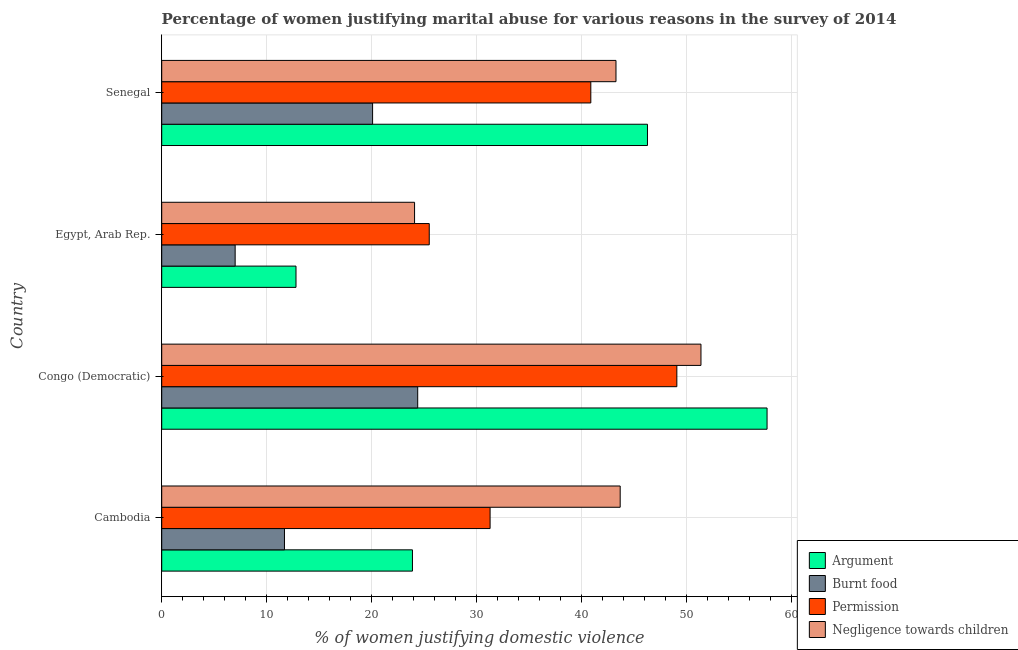How many different coloured bars are there?
Provide a succinct answer. 4. How many groups of bars are there?
Your answer should be compact. 4. Are the number of bars per tick equal to the number of legend labels?
Keep it short and to the point. Yes. How many bars are there on the 2nd tick from the bottom?
Your answer should be very brief. 4. What is the label of the 4th group of bars from the top?
Keep it short and to the point. Cambodia. What is the percentage of women justifying abuse for going without permission in Egypt, Arab Rep.?
Offer a very short reply. 25.5. Across all countries, what is the maximum percentage of women justifying abuse for burning food?
Give a very brief answer. 24.4. Across all countries, what is the minimum percentage of women justifying abuse for showing negligence towards children?
Ensure brevity in your answer.  24.1. In which country was the percentage of women justifying abuse for burning food maximum?
Provide a short and direct response. Congo (Democratic). In which country was the percentage of women justifying abuse for showing negligence towards children minimum?
Offer a very short reply. Egypt, Arab Rep. What is the total percentage of women justifying abuse for burning food in the graph?
Provide a succinct answer. 63.2. What is the difference between the percentage of women justifying abuse for going without permission in Cambodia and that in Senegal?
Make the answer very short. -9.6. What is the difference between the percentage of women justifying abuse in the case of an argument in Egypt, Arab Rep. and the percentage of women justifying abuse for going without permission in Cambodia?
Give a very brief answer. -18.5. What is the average percentage of women justifying abuse in the case of an argument per country?
Offer a very short reply. 35.17. What is the difference between the percentage of women justifying abuse in the case of an argument and percentage of women justifying abuse for showing negligence towards children in Congo (Democratic)?
Your answer should be very brief. 6.3. In how many countries, is the percentage of women justifying abuse in the case of an argument greater than 50 %?
Offer a terse response. 1. What is the ratio of the percentage of women justifying abuse in the case of an argument in Cambodia to that in Egypt, Arab Rep.?
Your answer should be compact. 1.87. Is the percentage of women justifying abuse for going without permission in Congo (Democratic) less than that in Senegal?
Keep it short and to the point. No. What is the difference between the highest and the lowest percentage of women justifying abuse for showing negligence towards children?
Ensure brevity in your answer.  27.3. In how many countries, is the percentage of women justifying abuse for showing negligence towards children greater than the average percentage of women justifying abuse for showing negligence towards children taken over all countries?
Provide a short and direct response. 3. Is the sum of the percentage of women justifying abuse for burning food in Egypt, Arab Rep. and Senegal greater than the maximum percentage of women justifying abuse for showing negligence towards children across all countries?
Provide a short and direct response. No. Is it the case that in every country, the sum of the percentage of women justifying abuse for going without permission and percentage of women justifying abuse in the case of an argument is greater than the sum of percentage of women justifying abuse for burning food and percentage of women justifying abuse for showing negligence towards children?
Provide a succinct answer. Yes. What does the 3rd bar from the top in Congo (Democratic) represents?
Your answer should be very brief. Burnt food. What does the 3rd bar from the bottom in Senegal represents?
Your response must be concise. Permission. How many bars are there?
Keep it short and to the point. 16. How many countries are there in the graph?
Give a very brief answer. 4. Does the graph contain grids?
Make the answer very short. Yes. Where does the legend appear in the graph?
Give a very brief answer. Bottom right. How many legend labels are there?
Your answer should be compact. 4. How are the legend labels stacked?
Make the answer very short. Vertical. What is the title of the graph?
Give a very brief answer. Percentage of women justifying marital abuse for various reasons in the survey of 2014. Does "European Union" appear as one of the legend labels in the graph?
Your answer should be very brief. No. What is the label or title of the X-axis?
Keep it short and to the point. % of women justifying domestic violence. What is the label or title of the Y-axis?
Ensure brevity in your answer.  Country. What is the % of women justifying domestic violence of Argument in Cambodia?
Your answer should be very brief. 23.9. What is the % of women justifying domestic violence of Permission in Cambodia?
Keep it short and to the point. 31.3. What is the % of women justifying domestic violence in Negligence towards children in Cambodia?
Give a very brief answer. 43.7. What is the % of women justifying domestic violence of Argument in Congo (Democratic)?
Offer a very short reply. 57.7. What is the % of women justifying domestic violence in Burnt food in Congo (Democratic)?
Make the answer very short. 24.4. What is the % of women justifying domestic violence in Permission in Congo (Democratic)?
Your answer should be compact. 49.1. What is the % of women justifying domestic violence of Negligence towards children in Congo (Democratic)?
Offer a terse response. 51.4. What is the % of women justifying domestic violence in Argument in Egypt, Arab Rep.?
Provide a succinct answer. 12.8. What is the % of women justifying domestic violence of Burnt food in Egypt, Arab Rep.?
Offer a terse response. 7. What is the % of women justifying domestic violence in Negligence towards children in Egypt, Arab Rep.?
Your answer should be compact. 24.1. What is the % of women justifying domestic violence in Argument in Senegal?
Your answer should be compact. 46.3. What is the % of women justifying domestic violence of Burnt food in Senegal?
Offer a very short reply. 20.1. What is the % of women justifying domestic violence of Permission in Senegal?
Your response must be concise. 40.9. What is the % of women justifying domestic violence of Negligence towards children in Senegal?
Give a very brief answer. 43.3. Across all countries, what is the maximum % of women justifying domestic violence of Argument?
Give a very brief answer. 57.7. Across all countries, what is the maximum % of women justifying domestic violence in Burnt food?
Your answer should be compact. 24.4. Across all countries, what is the maximum % of women justifying domestic violence of Permission?
Ensure brevity in your answer.  49.1. Across all countries, what is the maximum % of women justifying domestic violence of Negligence towards children?
Provide a short and direct response. 51.4. Across all countries, what is the minimum % of women justifying domestic violence of Argument?
Ensure brevity in your answer.  12.8. Across all countries, what is the minimum % of women justifying domestic violence in Burnt food?
Your answer should be very brief. 7. Across all countries, what is the minimum % of women justifying domestic violence in Permission?
Your answer should be compact. 25.5. Across all countries, what is the minimum % of women justifying domestic violence of Negligence towards children?
Your answer should be very brief. 24.1. What is the total % of women justifying domestic violence in Argument in the graph?
Keep it short and to the point. 140.7. What is the total % of women justifying domestic violence in Burnt food in the graph?
Your answer should be very brief. 63.2. What is the total % of women justifying domestic violence of Permission in the graph?
Offer a very short reply. 146.8. What is the total % of women justifying domestic violence in Negligence towards children in the graph?
Your answer should be very brief. 162.5. What is the difference between the % of women justifying domestic violence of Argument in Cambodia and that in Congo (Democratic)?
Provide a succinct answer. -33.8. What is the difference between the % of women justifying domestic violence of Permission in Cambodia and that in Congo (Democratic)?
Provide a short and direct response. -17.8. What is the difference between the % of women justifying domestic violence in Burnt food in Cambodia and that in Egypt, Arab Rep.?
Keep it short and to the point. 4.7. What is the difference between the % of women justifying domestic violence of Permission in Cambodia and that in Egypt, Arab Rep.?
Ensure brevity in your answer.  5.8. What is the difference between the % of women justifying domestic violence of Negligence towards children in Cambodia and that in Egypt, Arab Rep.?
Provide a short and direct response. 19.6. What is the difference between the % of women justifying domestic violence of Argument in Cambodia and that in Senegal?
Your response must be concise. -22.4. What is the difference between the % of women justifying domestic violence in Argument in Congo (Democratic) and that in Egypt, Arab Rep.?
Your answer should be very brief. 44.9. What is the difference between the % of women justifying domestic violence in Burnt food in Congo (Democratic) and that in Egypt, Arab Rep.?
Your response must be concise. 17.4. What is the difference between the % of women justifying domestic violence in Permission in Congo (Democratic) and that in Egypt, Arab Rep.?
Your response must be concise. 23.6. What is the difference between the % of women justifying domestic violence of Negligence towards children in Congo (Democratic) and that in Egypt, Arab Rep.?
Keep it short and to the point. 27.3. What is the difference between the % of women justifying domestic violence in Burnt food in Congo (Democratic) and that in Senegal?
Provide a succinct answer. 4.3. What is the difference between the % of women justifying domestic violence in Negligence towards children in Congo (Democratic) and that in Senegal?
Offer a terse response. 8.1. What is the difference between the % of women justifying domestic violence of Argument in Egypt, Arab Rep. and that in Senegal?
Give a very brief answer. -33.5. What is the difference between the % of women justifying domestic violence in Permission in Egypt, Arab Rep. and that in Senegal?
Ensure brevity in your answer.  -15.4. What is the difference between the % of women justifying domestic violence of Negligence towards children in Egypt, Arab Rep. and that in Senegal?
Offer a terse response. -19.2. What is the difference between the % of women justifying domestic violence in Argument in Cambodia and the % of women justifying domestic violence in Permission in Congo (Democratic)?
Your response must be concise. -25.2. What is the difference between the % of women justifying domestic violence of Argument in Cambodia and the % of women justifying domestic violence of Negligence towards children in Congo (Democratic)?
Make the answer very short. -27.5. What is the difference between the % of women justifying domestic violence in Burnt food in Cambodia and the % of women justifying domestic violence in Permission in Congo (Democratic)?
Ensure brevity in your answer.  -37.4. What is the difference between the % of women justifying domestic violence of Burnt food in Cambodia and the % of women justifying domestic violence of Negligence towards children in Congo (Democratic)?
Offer a terse response. -39.7. What is the difference between the % of women justifying domestic violence in Permission in Cambodia and the % of women justifying domestic violence in Negligence towards children in Congo (Democratic)?
Your response must be concise. -20.1. What is the difference between the % of women justifying domestic violence in Argument in Cambodia and the % of women justifying domestic violence in Burnt food in Egypt, Arab Rep.?
Your answer should be compact. 16.9. What is the difference between the % of women justifying domestic violence in Argument in Cambodia and the % of women justifying domestic violence in Permission in Egypt, Arab Rep.?
Give a very brief answer. -1.6. What is the difference between the % of women justifying domestic violence in Argument in Cambodia and the % of women justifying domestic violence in Negligence towards children in Egypt, Arab Rep.?
Ensure brevity in your answer.  -0.2. What is the difference between the % of women justifying domestic violence in Burnt food in Cambodia and the % of women justifying domestic violence in Negligence towards children in Egypt, Arab Rep.?
Your response must be concise. -12.4. What is the difference between the % of women justifying domestic violence in Permission in Cambodia and the % of women justifying domestic violence in Negligence towards children in Egypt, Arab Rep.?
Offer a terse response. 7.2. What is the difference between the % of women justifying domestic violence in Argument in Cambodia and the % of women justifying domestic violence in Burnt food in Senegal?
Provide a short and direct response. 3.8. What is the difference between the % of women justifying domestic violence of Argument in Cambodia and the % of women justifying domestic violence of Permission in Senegal?
Give a very brief answer. -17. What is the difference between the % of women justifying domestic violence of Argument in Cambodia and the % of women justifying domestic violence of Negligence towards children in Senegal?
Provide a succinct answer. -19.4. What is the difference between the % of women justifying domestic violence in Burnt food in Cambodia and the % of women justifying domestic violence in Permission in Senegal?
Offer a terse response. -29.2. What is the difference between the % of women justifying domestic violence in Burnt food in Cambodia and the % of women justifying domestic violence in Negligence towards children in Senegal?
Your answer should be compact. -31.6. What is the difference between the % of women justifying domestic violence of Permission in Cambodia and the % of women justifying domestic violence of Negligence towards children in Senegal?
Your answer should be compact. -12. What is the difference between the % of women justifying domestic violence in Argument in Congo (Democratic) and the % of women justifying domestic violence in Burnt food in Egypt, Arab Rep.?
Make the answer very short. 50.7. What is the difference between the % of women justifying domestic violence in Argument in Congo (Democratic) and the % of women justifying domestic violence in Permission in Egypt, Arab Rep.?
Give a very brief answer. 32.2. What is the difference between the % of women justifying domestic violence in Argument in Congo (Democratic) and the % of women justifying domestic violence in Negligence towards children in Egypt, Arab Rep.?
Ensure brevity in your answer.  33.6. What is the difference between the % of women justifying domestic violence of Burnt food in Congo (Democratic) and the % of women justifying domestic violence of Permission in Egypt, Arab Rep.?
Your answer should be compact. -1.1. What is the difference between the % of women justifying domestic violence in Burnt food in Congo (Democratic) and the % of women justifying domestic violence in Negligence towards children in Egypt, Arab Rep.?
Ensure brevity in your answer.  0.3. What is the difference between the % of women justifying domestic violence of Argument in Congo (Democratic) and the % of women justifying domestic violence of Burnt food in Senegal?
Provide a succinct answer. 37.6. What is the difference between the % of women justifying domestic violence in Argument in Congo (Democratic) and the % of women justifying domestic violence in Permission in Senegal?
Make the answer very short. 16.8. What is the difference between the % of women justifying domestic violence of Argument in Congo (Democratic) and the % of women justifying domestic violence of Negligence towards children in Senegal?
Offer a very short reply. 14.4. What is the difference between the % of women justifying domestic violence of Burnt food in Congo (Democratic) and the % of women justifying domestic violence of Permission in Senegal?
Provide a short and direct response. -16.5. What is the difference between the % of women justifying domestic violence of Burnt food in Congo (Democratic) and the % of women justifying domestic violence of Negligence towards children in Senegal?
Give a very brief answer. -18.9. What is the difference between the % of women justifying domestic violence of Permission in Congo (Democratic) and the % of women justifying domestic violence of Negligence towards children in Senegal?
Keep it short and to the point. 5.8. What is the difference between the % of women justifying domestic violence in Argument in Egypt, Arab Rep. and the % of women justifying domestic violence in Permission in Senegal?
Offer a terse response. -28.1. What is the difference between the % of women justifying domestic violence in Argument in Egypt, Arab Rep. and the % of women justifying domestic violence in Negligence towards children in Senegal?
Provide a short and direct response. -30.5. What is the difference between the % of women justifying domestic violence of Burnt food in Egypt, Arab Rep. and the % of women justifying domestic violence of Permission in Senegal?
Offer a very short reply. -33.9. What is the difference between the % of women justifying domestic violence of Burnt food in Egypt, Arab Rep. and the % of women justifying domestic violence of Negligence towards children in Senegal?
Ensure brevity in your answer.  -36.3. What is the difference between the % of women justifying domestic violence of Permission in Egypt, Arab Rep. and the % of women justifying domestic violence of Negligence towards children in Senegal?
Your answer should be very brief. -17.8. What is the average % of women justifying domestic violence in Argument per country?
Your response must be concise. 35.17. What is the average % of women justifying domestic violence of Burnt food per country?
Offer a terse response. 15.8. What is the average % of women justifying domestic violence in Permission per country?
Offer a terse response. 36.7. What is the average % of women justifying domestic violence of Negligence towards children per country?
Your response must be concise. 40.62. What is the difference between the % of women justifying domestic violence in Argument and % of women justifying domestic violence in Burnt food in Cambodia?
Your response must be concise. 12.2. What is the difference between the % of women justifying domestic violence in Argument and % of women justifying domestic violence in Permission in Cambodia?
Offer a very short reply. -7.4. What is the difference between the % of women justifying domestic violence of Argument and % of women justifying domestic violence of Negligence towards children in Cambodia?
Keep it short and to the point. -19.8. What is the difference between the % of women justifying domestic violence of Burnt food and % of women justifying domestic violence of Permission in Cambodia?
Make the answer very short. -19.6. What is the difference between the % of women justifying domestic violence in Burnt food and % of women justifying domestic violence in Negligence towards children in Cambodia?
Offer a very short reply. -32. What is the difference between the % of women justifying domestic violence of Permission and % of women justifying domestic violence of Negligence towards children in Cambodia?
Make the answer very short. -12.4. What is the difference between the % of women justifying domestic violence of Argument and % of women justifying domestic violence of Burnt food in Congo (Democratic)?
Your answer should be compact. 33.3. What is the difference between the % of women justifying domestic violence in Burnt food and % of women justifying domestic violence in Permission in Congo (Democratic)?
Make the answer very short. -24.7. What is the difference between the % of women justifying domestic violence of Burnt food and % of women justifying domestic violence of Negligence towards children in Congo (Democratic)?
Your answer should be compact. -27. What is the difference between the % of women justifying domestic violence of Permission and % of women justifying domestic violence of Negligence towards children in Congo (Democratic)?
Your answer should be compact. -2.3. What is the difference between the % of women justifying domestic violence of Burnt food and % of women justifying domestic violence of Permission in Egypt, Arab Rep.?
Offer a terse response. -18.5. What is the difference between the % of women justifying domestic violence of Burnt food and % of women justifying domestic violence of Negligence towards children in Egypt, Arab Rep.?
Provide a succinct answer. -17.1. What is the difference between the % of women justifying domestic violence in Argument and % of women justifying domestic violence in Burnt food in Senegal?
Keep it short and to the point. 26.2. What is the difference between the % of women justifying domestic violence in Argument and % of women justifying domestic violence in Permission in Senegal?
Ensure brevity in your answer.  5.4. What is the difference between the % of women justifying domestic violence of Burnt food and % of women justifying domestic violence of Permission in Senegal?
Make the answer very short. -20.8. What is the difference between the % of women justifying domestic violence in Burnt food and % of women justifying domestic violence in Negligence towards children in Senegal?
Provide a succinct answer. -23.2. What is the ratio of the % of women justifying domestic violence in Argument in Cambodia to that in Congo (Democratic)?
Make the answer very short. 0.41. What is the ratio of the % of women justifying domestic violence in Burnt food in Cambodia to that in Congo (Democratic)?
Your answer should be very brief. 0.48. What is the ratio of the % of women justifying domestic violence in Permission in Cambodia to that in Congo (Democratic)?
Your answer should be very brief. 0.64. What is the ratio of the % of women justifying domestic violence of Negligence towards children in Cambodia to that in Congo (Democratic)?
Offer a very short reply. 0.85. What is the ratio of the % of women justifying domestic violence of Argument in Cambodia to that in Egypt, Arab Rep.?
Ensure brevity in your answer.  1.87. What is the ratio of the % of women justifying domestic violence of Burnt food in Cambodia to that in Egypt, Arab Rep.?
Offer a very short reply. 1.67. What is the ratio of the % of women justifying domestic violence in Permission in Cambodia to that in Egypt, Arab Rep.?
Ensure brevity in your answer.  1.23. What is the ratio of the % of women justifying domestic violence in Negligence towards children in Cambodia to that in Egypt, Arab Rep.?
Your answer should be very brief. 1.81. What is the ratio of the % of women justifying domestic violence of Argument in Cambodia to that in Senegal?
Offer a very short reply. 0.52. What is the ratio of the % of women justifying domestic violence in Burnt food in Cambodia to that in Senegal?
Provide a succinct answer. 0.58. What is the ratio of the % of women justifying domestic violence in Permission in Cambodia to that in Senegal?
Offer a very short reply. 0.77. What is the ratio of the % of women justifying domestic violence in Negligence towards children in Cambodia to that in Senegal?
Offer a terse response. 1.01. What is the ratio of the % of women justifying domestic violence of Argument in Congo (Democratic) to that in Egypt, Arab Rep.?
Provide a succinct answer. 4.51. What is the ratio of the % of women justifying domestic violence in Burnt food in Congo (Democratic) to that in Egypt, Arab Rep.?
Provide a short and direct response. 3.49. What is the ratio of the % of women justifying domestic violence of Permission in Congo (Democratic) to that in Egypt, Arab Rep.?
Your answer should be compact. 1.93. What is the ratio of the % of women justifying domestic violence in Negligence towards children in Congo (Democratic) to that in Egypt, Arab Rep.?
Ensure brevity in your answer.  2.13. What is the ratio of the % of women justifying domestic violence of Argument in Congo (Democratic) to that in Senegal?
Your answer should be very brief. 1.25. What is the ratio of the % of women justifying domestic violence in Burnt food in Congo (Democratic) to that in Senegal?
Provide a succinct answer. 1.21. What is the ratio of the % of women justifying domestic violence in Permission in Congo (Democratic) to that in Senegal?
Your answer should be compact. 1.2. What is the ratio of the % of women justifying domestic violence in Negligence towards children in Congo (Democratic) to that in Senegal?
Give a very brief answer. 1.19. What is the ratio of the % of women justifying domestic violence of Argument in Egypt, Arab Rep. to that in Senegal?
Your answer should be very brief. 0.28. What is the ratio of the % of women justifying domestic violence of Burnt food in Egypt, Arab Rep. to that in Senegal?
Ensure brevity in your answer.  0.35. What is the ratio of the % of women justifying domestic violence in Permission in Egypt, Arab Rep. to that in Senegal?
Provide a succinct answer. 0.62. What is the ratio of the % of women justifying domestic violence in Negligence towards children in Egypt, Arab Rep. to that in Senegal?
Your answer should be compact. 0.56. What is the difference between the highest and the second highest % of women justifying domestic violence in Argument?
Your response must be concise. 11.4. What is the difference between the highest and the second highest % of women justifying domestic violence in Burnt food?
Provide a succinct answer. 4.3. What is the difference between the highest and the second highest % of women justifying domestic violence in Permission?
Offer a terse response. 8.2. What is the difference between the highest and the second highest % of women justifying domestic violence of Negligence towards children?
Offer a very short reply. 7.7. What is the difference between the highest and the lowest % of women justifying domestic violence in Argument?
Give a very brief answer. 44.9. What is the difference between the highest and the lowest % of women justifying domestic violence in Burnt food?
Offer a very short reply. 17.4. What is the difference between the highest and the lowest % of women justifying domestic violence of Permission?
Make the answer very short. 23.6. What is the difference between the highest and the lowest % of women justifying domestic violence in Negligence towards children?
Offer a very short reply. 27.3. 